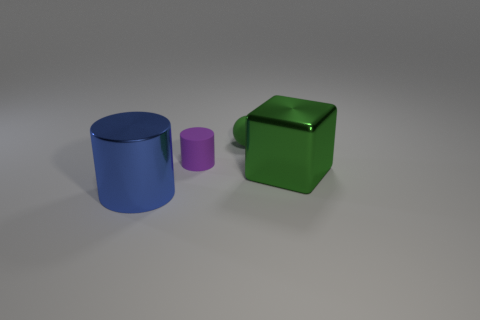There is a matte ball that is the same color as the metallic cube; what size is it?
Give a very brief answer. Small. Is there a cyan thing that has the same shape as the tiny purple rubber object?
Give a very brief answer. No. What shape is the tiny rubber thing that is the same color as the big metal cube?
Provide a succinct answer. Sphere. There is a large metallic object on the right side of the matte object in front of the tiny green rubber sphere; is there a large blue cylinder on the right side of it?
Offer a terse response. No. There is a purple rubber object that is the same size as the green ball; what is its shape?
Offer a very short reply. Cylinder. There is a large object that is the same shape as the tiny purple matte thing; what color is it?
Your answer should be compact. Blue. How many things are either metal cubes or tiny blue metal cubes?
Your answer should be compact. 1. Is the shape of the green thing that is right of the sphere the same as the small rubber object that is in front of the small green ball?
Provide a succinct answer. No. There is a small object on the right side of the tiny cylinder; what shape is it?
Make the answer very short. Sphere. Is the number of objects that are on the right side of the large green shiny object the same as the number of small balls to the right of the sphere?
Provide a short and direct response. Yes. 